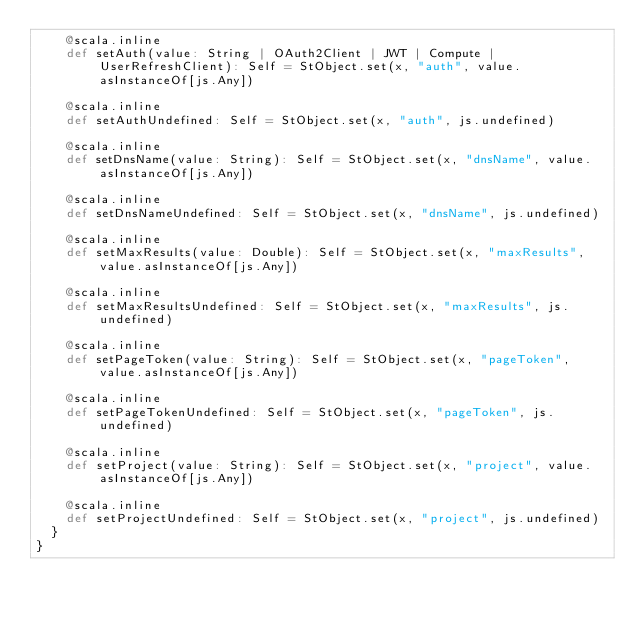<code> <loc_0><loc_0><loc_500><loc_500><_Scala_>    @scala.inline
    def setAuth(value: String | OAuth2Client | JWT | Compute | UserRefreshClient): Self = StObject.set(x, "auth", value.asInstanceOf[js.Any])
    
    @scala.inline
    def setAuthUndefined: Self = StObject.set(x, "auth", js.undefined)
    
    @scala.inline
    def setDnsName(value: String): Self = StObject.set(x, "dnsName", value.asInstanceOf[js.Any])
    
    @scala.inline
    def setDnsNameUndefined: Self = StObject.set(x, "dnsName", js.undefined)
    
    @scala.inline
    def setMaxResults(value: Double): Self = StObject.set(x, "maxResults", value.asInstanceOf[js.Any])
    
    @scala.inline
    def setMaxResultsUndefined: Self = StObject.set(x, "maxResults", js.undefined)
    
    @scala.inline
    def setPageToken(value: String): Self = StObject.set(x, "pageToken", value.asInstanceOf[js.Any])
    
    @scala.inline
    def setPageTokenUndefined: Self = StObject.set(x, "pageToken", js.undefined)
    
    @scala.inline
    def setProject(value: String): Self = StObject.set(x, "project", value.asInstanceOf[js.Any])
    
    @scala.inline
    def setProjectUndefined: Self = StObject.set(x, "project", js.undefined)
  }
}
</code> 